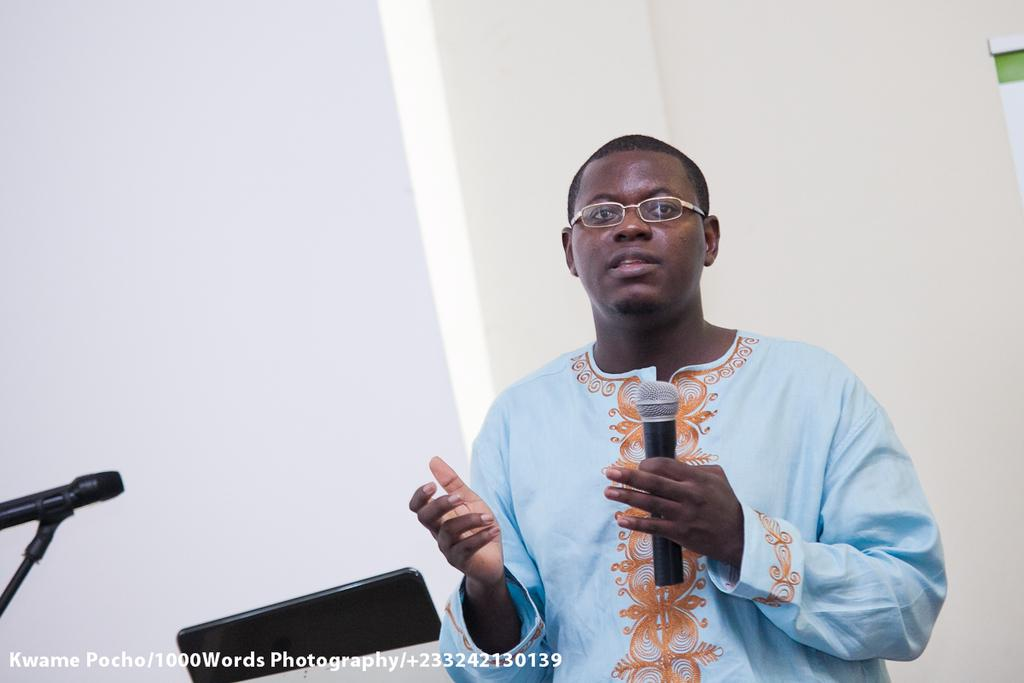What is the main subject of the image? There is a man in the image. What is the man holding in the image? The man is holding a mic. What type of collar is the man wearing in the image? There is no collar visible in the image, as the man is not wearing any clothing. What type of play is the man participating in while holding the mic? There is no indication of a play or any specific activity in the image, as it only shows the man holding a mic. 